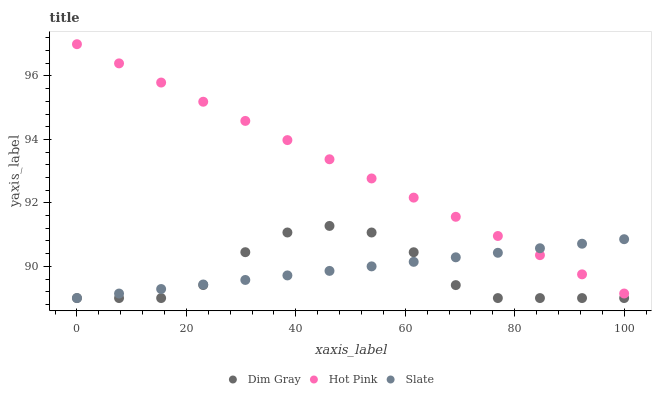Does Dim Gray have the minimum area under the curve?
Answer yes or no. Yes. Does Hot Pink have the maximum area under the curve?
Answer yes or no. Yes. Does Hot Pink have the minimum area under the curve?
Answer yes or no. No. Does Dim Gray have the maximum area under the curve?
Answer yes or no. No. Is Hot Pink the smoothest?
Answer yes or no. Yes. Is Dim Gray the roughest?
Answer yes or no. Yes. Is Dim Gray the smoothest?
Answer yes or no. No. Is Hot Pink the roughest?
Answer yes or no. No. Does Slate have the lowest value?
Answer yes or no. Yes. Does Hot Pink have the lowest value?
Answer yes or no. No. Does Hot Pink have the highest value?
Answer yes or no. Yes. Does Dim Gray have the highest value?
Answer yes or no. No. Is Dim Gray less than Hot Pink?
Answer yes or no. Yes. Is Hot Pink greater than Dim Gray?
Answer yes or no. Yes. Does Slate intersect Dim Gray?
Answer yes or no. Yes. Is Slate less than Dim Gray?
Answer yes or no. No. Is Slate greater than Dim Gray?
Answer yes or no. No. Does Dim Gray intersect Hot Pink?
Answer yes or no. No. 